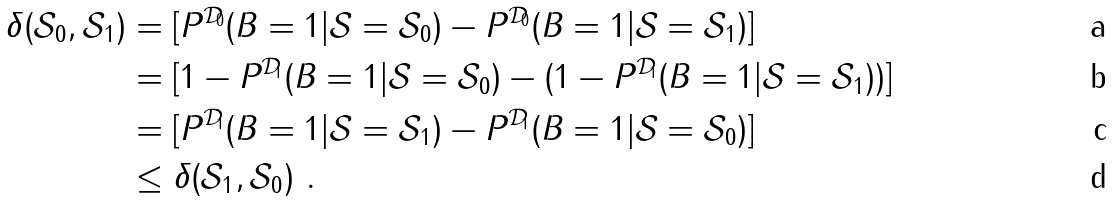<formula> <loc_0><loc_0><loc_500><loc_500>\delta ( \mathcal { S } _ { 0 } , \mathcal { S } _ { 1 } ) & = [ P ^ { \mathcal { D } _ { 0 } } ( B = 1 | \mathcal { S } = \mathcal { S } _ { 0 } ) - P ^ { \mathcal { D } _ { 0 } } ( B = 1 | \mathcal { S } = \mathcal { S } _ { 1 } ) ] \\ & = [ 1 - P ^ { \mathcal { D } _ { 1 } } ( B = 1 | \mathcal { S } = \mathcal { S } _ { 0 } ) - ( 1 - P ^ { \mathcal { D } _ { 1 } } ( B = 1 | \mathcal { S } = \mathcal { S } _ { 1 } ) ) ] \\ & = [ P ^ { \mathcal { D } _ { 1 } } ( B = 1 | \mathcal { S } = \mathcal { S } _ { 1 } ) - P ^ { \mathcal { D } _ { 1 } } ( B = 1 | \mathcal { S } = \mathcal { S } _ { 0 } ) ] \\ & \leq \delta ( \mathcal { S } _ { 1 } , \mathcal { S } _ { 0 } ) \ .</formula> 